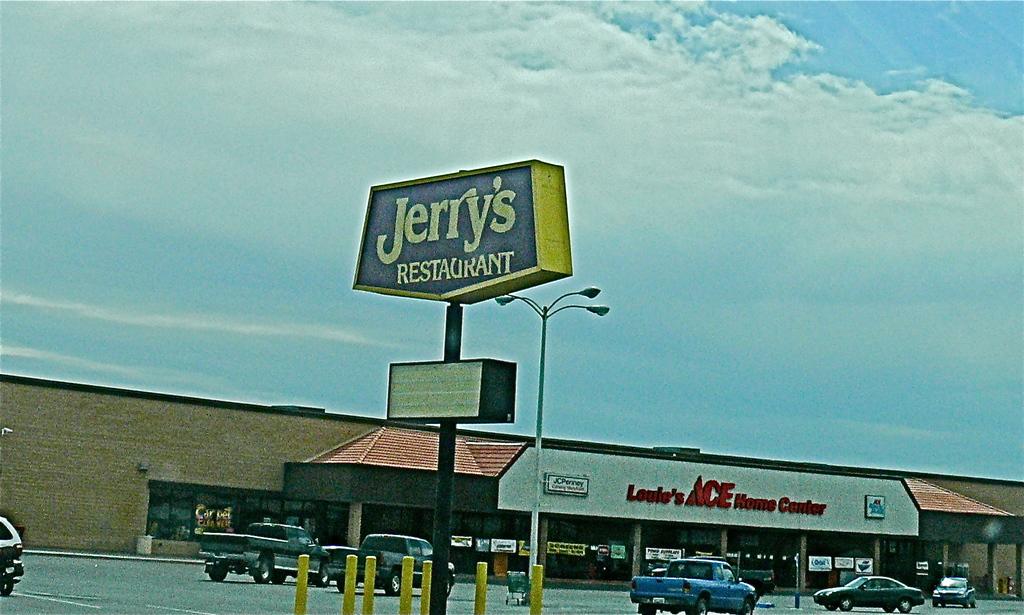What chain hardware store is here?
Provide a short and direct response. Ace. What is the name of this restaurant?
Provide a succinct answer. Jerry's. 